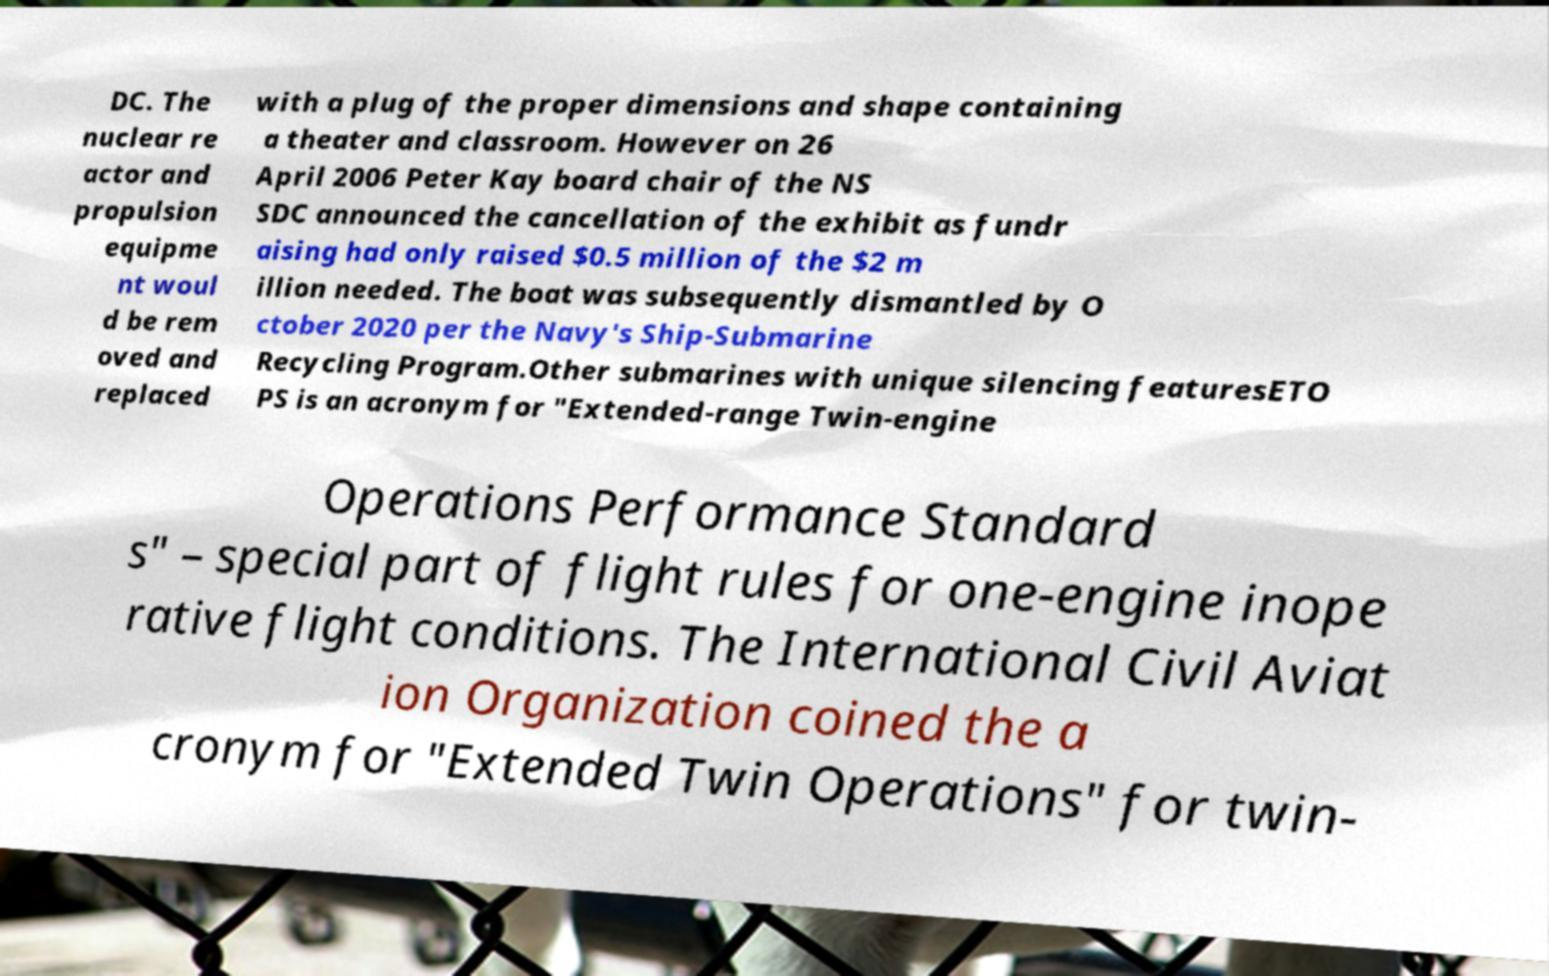Can you accurately transcribe the text from the provided image for me? DC. The nuclear re actor and propulsion equipme nt woul d be rem oved and replaced with a plug of the proper dimensions and shape containing a theater and classroom. However on 26 April 2006 Peter Kay board chair of the NS SDC announced the cancellation of the exhibit as fundr aising had only raised $0.5 million of the $2 m illion needed. The boat was subsequently dismantled by O ctober 2020 per the Navy's Ship-Submarine Recycling Program.Other submarines with unique silencing featuresETO PS is an acronym for "Extended-range Twin-engine Operations Performance Standard s" – special part of flight rules for one-engine inope rative flight conditions. The International Civil Aviat ion Organization coined the a cronym for "Extended Twin Operations" for twin- 